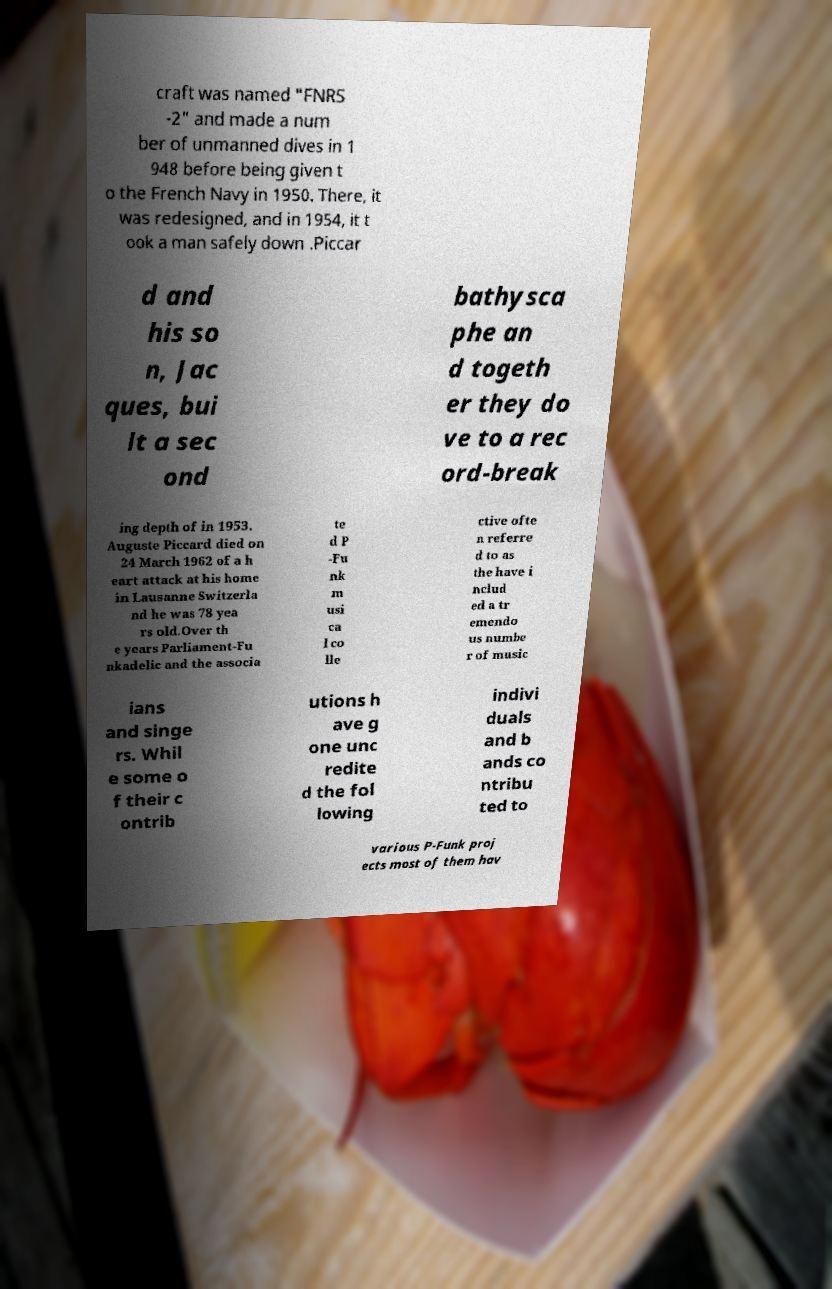Please identify and transcribe the text found in this image. craft was named "FNRS -2" and made a num ber of unmanned dives in 1 948 before being given t o the French Navy in 1950. There, it was redesigned, and in 1954, it t ook a man safely down .Piccar d and his so n, Jac ques, bui lt a sec ond bathysca phe an d togeth er they do ve to a rec ord-break ing depth of in 1953. Auguste Piccard died on 24 March 1962 of a h eart attack at his home in Lausanne Switzerla nd he was 78 yea rs old.Over th e years Parliament-Fu nkadelic and the associa te d P -Fu nk m usi ca l co lle ctive ofte n referre d to as the have i nclud ed a tr emendo us numbe r of music ians and singe rs. Whil e some o f their c ontrib utions h ave g one unc redite d the fol lowing indivi duals and b ands co ntribu ted to various P-Funk proj ects most of them hav 